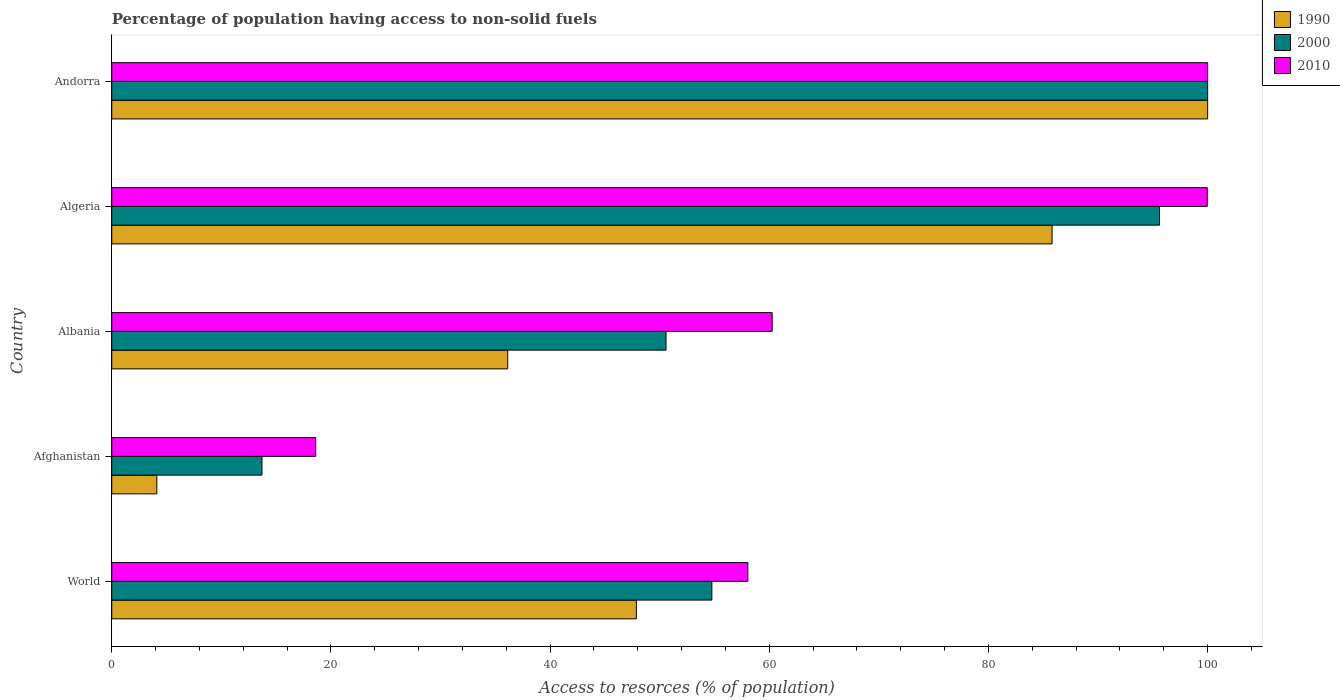Are the number of bars per tick equal to the number of legend labels?
Your answer should be very brief. Yes. Are the number of bars on each tick of the Y-axis equal?
Your answer should be very brief. Yes. How many bars are there on the 3rd tick from the top?
Give a very brief answer. 3. How many bars are there on the 2nd tick from the bottom?
Make the answer very short. 3. What is the label of the 3rd group of bars from the top?
Offer a very short reply. Albania. In how many cases, is the number of bars for a given country not equal to the number of legend labels?
Provide a succinct answer. 0. What is the percentage of population having access to non-solid fuels in 2000 in Andorra?
Make the answer very short. 100. Across all countries, what is the minimum percentage of population having access to non-solid fuels in 2000?
Keep it short and to the point. 13.71. In which country was the percentage of population having access to non-solid fuels in 2010 maximum?
Offer a very short reply. Andorra. In which country was the percentage of population having access to non-solid fuels in 1990 minimum?
Offer a terse response. Afghanistan. What is the total percentage of population having access to non-solid fuels in 2010 in the graph?
Offer a terse response. 336.88. What is the difference between the percentage of population having access to non-solid fuels in 2010 in Afghanistan and that in Andorra?
Provide a short and direct response. -81.39. What is the difference between the percentage of population having access to non-solid fuels in 1990 in Algeria and the percentage of population having access to non-solid fuels in 2010 in Andorra?
Make the answer very short. -14.2. What is the average percentage of population having access to non-solid fuels in 1990 per country?
Your answer should be compact. 54.78. What is the difference between the percentage of population having access to non-solid fuels in 1990 and percentage of population having access to non-solid fuels in 2010 in World?
Give a very brief answer. -10.17. What is the ratio of the percentage of population having access to non-solid fuels in 1990 in Afghanistan to that in World?
Your response must be concise. 0.09. Is the percentage of population having access to non-solid fuels in 2000 in Afghanistan less than that in Algeria?
Keep it short and to the point. Yes. Is the difference between the percentage of population having access to non-solid fuels in 1990 in Afghanistan and Andorra greater than the difference between the percentage of population having access to non-solid fuels in 2010 in Afghanistan and Andorra?
Make the answer very short. No. What is the difference between the highest and the second highest percentage of population having access to non-solid fuels in 1990?
Provide a short and direct response. 14.2. What is the difference between the highest and the lowest percentage of population having access to non-solid fuels in 2010?
Give a very brief answer. 81.39. Is the sum of the percentage of population having access to non-solid fuels in 2000 in Albania and Algeria greater than the maximum percentage of population having access to non-solid fuels in 1990 across all countries?
Your answer should be very brief. Yes. What does the 2nd bar from the top in World represents?
Keep it short and to the point. 2000. What does the 3rd bar from the bottom in Albania represents?
Provide a short and direct response. 2010. Is it the case that in every country, the sum of the percentage of population having access to non-solid fuels in 1990 and percentage of population having access to non-solid fuels in 2000 is greater than the percentage of population having access to non-solid fuels in 2010?
Your answer should be compact. No. What is the difference between two consecutive major ticks on the X-axis?
Ensure brevity in your answer.  20. Where does the legend appear in the graph?
Your response must be concise. Top right. What is the title of the graph?
Give a very brief answer. Percentage of population having access to non-solid fuels. What is the label or title of the X-axis?
Give a very brief answer. Access to resorces (% of population). What is the label or title of the Y-axis?
Offer a terse response. Country. What is the Access to resorces (% of population) in 1990 in World?
Your answer should be compact. 47.87. What is the Access to resorces (% of population) in 2000 in World?
Offer a very short reply. 54.76. What is the Access to resorces (% of population) in 2010 in World?
Keep it short and to the point. 58.04. What is the Access to resorces (% of population) of 1990 in Afghanistan?
Provide a succinct answer. 4.11. What is the Access to resorces (% of population) in 2000 in Afghanistan?
Your response must be concise. 13.71. What is the Access to resorces (% of population) of 2010 in Afghanistan?
Provide a succinct answer. 18.61. What is the Access to resorces (% of population) of 1990 in Albania?
Provide a succinct answer. 36.13. What is the Access to resorces (% of population) in 2000 in Albania?
Provide a succinct answer. 50.58. What is the Access to resorces (% of population) in 2010 in Albania?
Ensure brevity in your answer.  60.26. What is the Access to resorces (% of population) in 1990 in Algeria?
Offer a terse response. 85.8. What is the Access to resorces (% of population) in 2000 in Algeria?
Give a very brief answer. 95.61. What is the Access to resorces (% of population) in 2010 in Algeria?
Your answer should be very brief. 99.96. What is the Access to resorces (% of population) of 1990 in Andorra?
Keep it short and to the point. 100. What is the Access to resorces (% of population) of 2000 in Andorra?
Your response must be concise. 100. What is the Access to resorces (% of population) in 2010 in Andorra?
Provide a short and direct response. 100. Across all countries, what is the maximum Access to resorces (% of population) in 2010?
Provide a short and direct response. 100. Across all countries, what is the minimum Access to resorces (% of population) of 1990?
Give a very brief answer. 4.11. Across all countries, what is the minimum Access to resorces (% of population) of 2000?
Your answer should be compact. 13.71. Across all countries, what is the minimum Access to resorces (% of population) in 2010?
Give a very brief answer. 18.61. What is the total Access to resorces (% of population) of 1990 in the graph?
Offer a very short reply. 273.93. What is the total Access to resorces (% of population) of 2000 in the graph?
Your response must be concise. 314.66. What is the total Access to resorces (% of population) of 2010 in the graph?
Your answer should be very brief. 336.88. What is the difference between the Access to resorces (% of population) in 1990 in World and that in Afghanistan?
Provide a succinct answer. 43.76. What is the difference between the Access to resorces (% of population) of 2000 in World and that in Afghanistan?
Keep it short and to the point. 41.05. What is the difference between the Access to resorces (% of population) of 2010 in World and that in Afghanistan?
Offer a terse response. 39.43. What is the difference between the Access to resorces (% of population) in 1990 in World and that in Albania?
Your response must be concise. 11.74. What is the difference between the Access to resorces (% of population) of 2000 in World and that in Albania?
Give a very brief answer. 4.18. What is the difference between the Access to resorces (% of population) of 2010 in World and that in Albania?
Offer a terse response. -2.22. What is the difference between the Access to resorces (% of population) in 1990 in World and that in Algeria?
Keep it short and to the point. -37.93. What is the difference between the Access to resorces (% of population) in 2000 in World and that in Algeria?
Your answer should be compact. -40.85. What is the difference between the Access to resorces (% of population) in 2010 in World and that in Algeria?
Your answer should be very brief. -41.92. What is the difference between the Access to resorces (% of population) of 1990 in World and that in Andorra?
Your response must be concise. -52.13. What is the difference between the Access to resorces (% of population) in 2000 in World and that in Andorra?
Provide a succinct answer. -45.24. What is the difference between the Access to resorces (% of population) in 2010 in World and that in Andorra?
Your response must be concise. -41.96. What is the difference between the Access to resorces (% of population) of 1990 in Afghanistan and that in Albania?
Your answer should be very brief. -32.02. What is the difference between the Access to resorces (% of population) in 2000 in Afghanistan and that in Albania?
Your response must be concise. -36.87. What is the difference between the Access to resorces (% of population) in 2010 in Afghanistan and that in Albania?
Give a very brief answer. -41.65. What is the difference between the Access to resorces (% of population) in 1990 in Afghanistan and that in Algeria?
Your response must be concise. -81.69. What is the difference between the Access to resorces (% of population) in 2000 in Afghanistan and that in Algeria?
Provide a short and direct response. -81.9. What is the difference between the Access to resorces (% of population) of 2010 in Afghanistan and that in Algeria?
Keep it short and to the point. -81.35. What is the difference between the Access to resorces (% of population) in 1990 in Afghanistan and that in Andorra?
Keep it short and to the point. -95.89. What is the difference between the Access to resorces (% of population) of 2000 in Afghanistan and that in Andorra?
Your answer should be very brief. -86.29. What is the difference between the Access to resorces (% of population) of 2010 in Afghanistan and that in Andorra?
Offer a very short reply. -81.39. What is the difference between the Access to resorces (% of population) of 1990 in Albania and that in Algeria?
Your answer should be very brief. -49.67. What is the difference between the Access to resorces (% of population) of 2000 in Albania and that in Algeria?
Make the answer very short. -45.03. What is the difference between the Access to resorces (% of population) of 2010 in Albania and that in Algeria?
Provide a succinct answer. -39.7. What is the difference between the Access to resorces (% of population) in 1990 in Albania and that in Andorra?
Your answer should be very brief. -63.87. What is the difference between the Access to resorces (% of population) in 2000 in Albania and that in Andorra?
Your response must be concise. -49.42. What is the difference between the Access to resorces (% of population) in 2010 in Albania and that in Andorra?
Provide a short and direct response. -39.74. What is the difference between the Access to resorces (% of population) in 1990 in Algeria and that in Andorra?
Provide a short and direct response. -14.2. What is the difference between the Access to resorces (% of population) of 2000 in Algeria and that in Andorra?
Your answer should be very brief. -4.39. What is the difference between the Access to resorces (% of population) in 2010 in Algeria and that in Andorra?
Make the answer very short. -0.04. What is the difference between the Access to resorces (% of population) in 1990 in World and the Access to resorces (% of population) in 2000 in Afghanistan?
Provide a short and direct response. 34.17. What is the difference between the Access to resorces (% of population) in 1990 in World and the Access to resorces (% of population) in 2010 in Afghanistan?
Give a very brief answer. 29.26. What is the difference between the Access to resorces (% of population) in 2000 in World and the Access to resorces (% of population) in 2010 in Afghanistan?
Offer a very short reply. 36.15. What is the difference between the Access to resorces (% of population) in 1990 in World and the Access to resorces (% of population) in 2000 in Albania?
Provide a succinct answer. -2.7. What is the difference between the Access to resorces (% of population) in 1990 in World and the Access to resorces (% of population) in 2010 in Albania?
Provide a short and direct response. -12.39. What is the difference between the Access to resorces (% of population) of 2000 in World and the Access to resorces (% of population) of 2010 in Albania?
Give a very brief answer. -5.5. What is the difference between the Access to resorces (% of population) of 1990 in World and the Access to resorces (% of population) of 2000 in Algeria?
Ensure brevity in your answer.  -47.74. What is the difference between the Access to resorces (% of population) of 1990 in World and the Access to resorces (% of population) of 2010 in Algeria?
Make the answer very short. -52.09. What is the difference between the Access to resorces (% of population) of 2000 in World and the Access to resorces (% of population) of 2010 in Algeria?
Your answer should be compact. -45.2. What is the difference between the Access to resorces (% of population) of 1990 in World and the Access to resorces (% of population) of 2000 in Andorra?
Offer a terse response. -52.13. What is the difference between the Access to resorces (% of population) of 1990 in World and the Access to resorces (% of population) of 2010 in Andorra?
Your answer should be compact. -52.13. What is the difference between the Access to resorces (% of population) of 2000 in World and the Access to resorces (% of population) of 2010 in Andorra?
Give a very brief answer. -45.24. What is the difference between the Access to resorces (% of population) of 1990 in Afghanistan and the Access to resorces (% of population) of 2000 in Albania?
Provide a short and direct response. -46.47. What is the difference between the Access to resorces (% of population) in 1990 in Afghanistan and the Access to resorces (% of population) in 2010 in Albania?
Provide a succinct answer. -56.15. What is the difference between the Access to resorces (% of population) of 2000 in Afghanistan and the Access to resorces (% of population) of 2010 in Albania?
Make the answer very short. -46.56. What is the difference between the Access to resorces (% of population) of 1990 in Afghanistan and the Access to resorces (% of population) of 2000 in Algeria?
Provide a succinct answer. -91.5. What is the difference between the Access to resorces (% of population) of 1990 in Afghanistan and the Access to resorces (% of population) of 2010 in Algeria?
Give a very brief answer. -95.85. What is the difference between the Access to resorces (% of population) in 2000 in Afghanistan and the Access to resorces (% of population) in 2010 in Algeria?
Your answer should be very brief. -86.25. What is the difference between the Access to resorces (% of population) in 1990 in Afghanistan and the Access to resorces (% of population) in 2000 in Andorra?
Offer a very short reply. -95.89. What is the difference between the Access to resorces (% of population) in 1990 in Afghanistan and the Access to resorces (% of population) in 2010 in Andorra?
Make the answer very short. -95.89. What is the difference between the Access to resorces (% of population) of 2000 in Afghanistan and the Access to resorces (% of population) of 2010 in Andorra?
Offer a terse response. -86.29. What is the difference between the Access to resorces (% of population) of 1990 in Albania and the Access to resorces (% of population) of 2000 in Algeria?
Make the answer very short. -59.48. What is the difference between the Access to resorces (% of population) in 1990 in Albania and the Access to resorces (% of population) in 2010 in Algeria?
Ensure brevity in your answer.  -63.83. What is the difference between the Access to resorces (% of population) of 2000 in Albania and the Access to resorces (% of population) of 2010 in Algeria?
Offer a terse response. -49.39. What is the difference between the Access to resorces (% of population) in 1990 in Albania and the Access to resorces (% of population) in 2000 in Andorra?
Offer a very short reply. -63.87. What is the difference between the Access to resorces (% of population) in 1990 in Albania and the Access to resorces (% of population) in 2010 in Andorra?
Ensure brevity in your answer.  -63.87. What is the difference between the Access to resorces (% of population) of 2000 in Albania and the Access to resorces (% of population) of 2010 in Andorra?
Give a very brief answer. -49.42. What is the difference between the Access to resorces (% of population) of 1990 in Algeria and the Access to resorces (% of population) of 2000 in Andorra?
Provide a short and direct response. -14.2. What is the difference between the Access to resorces (% of population) of 1990 in Algeria and the Access to resorces (% of population) of 2010 in Andorra?
Keep it short and to the point. -14.2. What is the difference between the Access to resorces (% of population) in 2000 in Algeria and the Access to resorces (% of population) in 2010 in Andorra?
Your answer should be compact. -4.39. What is the average Access to resorces (% of population) in 1990 per country?
Keep it short and to the point. 54.78. What is the average Access to resorces (% of population) of 2000 per country?
Your response must be concise. 62.93. What is the average Access to resorces (% of population) of 2010 per country?
Your answer should be very brief. 67.38. What is the difference between the Access to resorces (% of population) in 1990 and Access to resorces (% of population) in 2000 in World?
Provide a succinct answer. -6.89. What is the difference between the Access to resorces (% of population) in 1990 and Access to resorces (% of population) in 2010 in World?
Make the answer very short. -10.17. What is the difference between the Access to resorces (% of population) in 2000 and Access to resorces (% of population) in 2010 in World?
Provide a succinct answer. -3.28. What is the difference between the Access to resorces (% of population) in 1990 and Access to resorces (% of population) in 2000 in Afghanistan?
Keep it short and to the point. -9.6. What is the difference between the Access to resorces (% of population) in 1990 and Access to resorces (% of population) in 2010 in Afghanistan?
Offer a terse response. -14.5. What is the difference between the Access to resorces (% of population) of 2000 and Access to resorces (% of population) of 2010 in Afghanistan?
Offer a very short reply. -4.9. What is the difference between the Access to resorces (% of population) of 1990 and Access to resorces (% of population) of 2000 in Albania?
Make the answer very short. -14.44. What is the difference between the Access to resorces (% of population) of 1990 and Access to resorces (% of population) of 2010 in Albania?
Make the answer very short. -24.13. What is the difference between the Access to resorces (% of population) in 2000 and Access to resorces (% of population) in 2010 in Albania?
Provide a short and direct response. -9.69. What is the difference between the Access to resorces (% of population) of 1990 and Access to resorces (% of population) of 2000 in Algeria?
Your response must be concise. -9.81. What is the difference between the Access to resorces (% of population) in 1990 and Access to resorces (% of population) in 2010 in Algeria?
Ensure brevity in your answer.  -14.16. What is the difference between the Access to resorces (% of population) in 2000 and Access to resorces (% of population) in 2010 in Algeria?
Your answer should be very brief. -4.35. What is the difference between the Access to resorces (% of population) in 1990 and Access to resorces (% of population) in 2010 in Andorra?
Provide a short and direct response. 0. What is the ratio of the Access to resorces (% of population) of 1990 in World to that in Afghanistan?
Give a very brief answer. 11.64. What is the ratio of the Access to resorces (% of population) of 2000 in World to that in Afghanistan?
Offer a very short reply. 3.99. What is the ratio of the Access to resorces (% of population) of 2010 in World to that in Afghanistan?
Provide a short and direct response. 3.12. What is the ratio of the Access to resorces (% of population) of 1990 in World to that in Albania?
Ensure brevity in your answer.  1.32. What is the ratio of the Access to resorces (% of population) in 2000 in World to that in Albania?
Your answer should be compact. 1.08. What is the ratio of the Access to resorces (% of population) of 2010 in World to that in Albania?
Offer a terse response. 0.96. What is the ratio of the Access to resorces (% of population) of 1990 in World to that in Algeria?
Offer a very short reply. 0.56. What is the ratio of the Access to resorces (% of population) of 2000 in World to that in Algeria?
Provide a succinct answer. 0.57. What is the ratio of the Access to resorces (% of population) of 2010 in World to that in Algeria?
Offer a terse response. 0.58. What is the ratio of the Access to resorces (% of population) of 1990 in World to that in Andorra?
Give a very brief answer. 0.48. What is the ratio of the Access to resorces (% of population) of 2000 in World to that in Andorra?
Provide a short and direct response. 0.55. What is the ratio of the Access to resorces (% of population) in 2010 in World to that in Andorra?
Offer a very short reply. 0.58. What is the ratio of the Access to resorces (% of population) of 1990 in Afghanistan to that in Albania?
Offer a terse response. 0.11. What is the ratio of the Access to resorces (% of population) in 2000 in Afghanistan to that in Albania?
Offer a terse response. 0.27. What is the ratio of the Access to resorces (% of population) in 2010 in Afghanistan to that in Albania?
Your answer should be compact. 0.31. What is the ratio of the Access to resorces (% of population) in 1990 in Afghanistan to that in Algeria?
Offer a terse response. 0.05. What is the ratio of the Access to resorces (% of population) in 2000 in Afghanistan to that in Algeria?
Your response must be concise. 0.14. What is the ratio of the Access to resorces (% of population) of 2010 in Afghanistan to that in Algeria?
Your response must be concise. 0.19. What is the ratio of the Access to resorces (% of population) in 1990 in Afghanistan to that in Andorra?
Your answer should be compact. 0.04. What is the ratio of the Access to resorces (% of population) of 2000 in Afghanistan to that in Andorra?
Make the answer very short. 0.14. What is the ratio of the Access to resorces (% of population) in 2010 in Afghanistan to that in Andorra?
Your answer should be very brief. 0.19. What is the ratio of the Access to resorces (% of population) of 1990 in Albania to that in Algeria?
Offer a very short reply. 0.42. What is the ratio of the Access to resorces (% of population) in 2000 in Albania to that in Algeria?
Offer a terse response. 0.53. What is the ratio of the Access to resorces (% of population) of 2010 in Albania to that in Algeria?
Provide a short and direct response. 0.6. What is the ratio of the Access to resorces (% of population) in 1990 in Albania to that in Andorra?
Your answer should be very brief. 0.36. What is the ratio of the Access to resorces (% of population) in 2000 in Albania to that in Andorra?
Keep it short and to the point. 0.51. What is the ratio of the Access to resorces (% of population) in 2010 in Albania to that in Andorra?
Offer a very short reply. 0.6. What is the ratio of the Access to resorces (% of population) of 1990 in Algeria to that in Andorra?
Make the answer very short. 0.86. What is the ratio of the Access to resorces (% of population) in 2000 in Algeria to that in Andorra?
Give a very brief answer. 0.96. What is the ratio of the Access to resorces (% of population) in 2010 in Algeria to that in Andorra?
Offer a very short reply. 1. What is the difference between the highest and the second highest Access to resorces (% of population) of 1990?
Offer a terse response. 14.2. What is the difference between the highest and the second highest Access to resorces (% of population) in 2000?
Your answer should be compact. 4.39. What is the difference between the highest and the second highest Access to resorces (% of population) of 2010?
Give a very brief answer. 0.04. What is the difference between the highest and the lowest Access to resorces (% of population) of 1990?
Provide a succinct answer. 95.89. What is the difference between the highest and the lowest Access to resorces (% of population) of 2000?
Offer a terse response. 86.29. What is the difference between the highest and the lowest Access to resorces (% of population) of 2010?
Your answer should be compact. 81.39. 